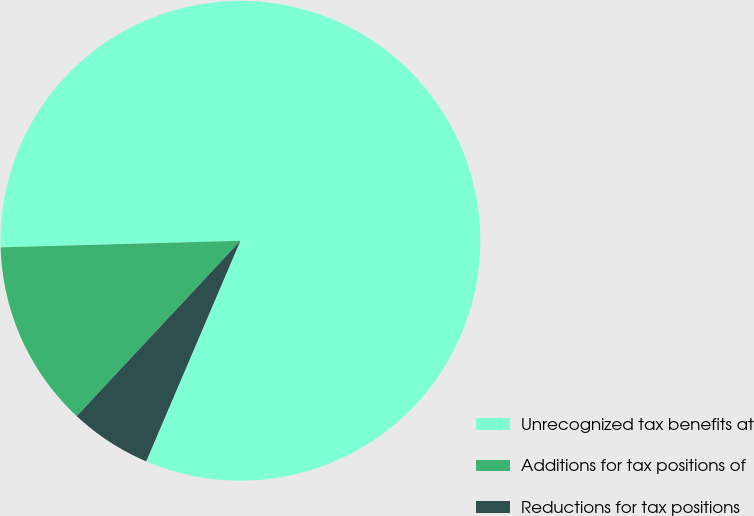Convert chart. <chart><loc_0><loc_0><loc_500><loc_500><pie_chart><fcel>Unrecognized tax benefits at<fcel>Additions for tax positions of<fcel>Reductions for tax positions<nl><fcel>81.85%<fcel>12.61%<fcel>5.53%<nl></chart> 